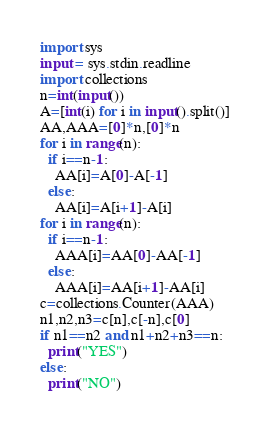<code> <loc_0><loc_0><loc_500><loc_500><_Python_>import sys
input = sys.stdin.readline
import collections
n=int(input())
A=[int(i) for i in input().split()]
AA,AAA=[0]*n,[0]*n
for i in range(n):
  if i==n-1:
    AA[i]=A[0]-A[-1]
  else:
    AA[i]=A[i+1]-A[i]
for i in range(n):
  if i==n-1:
    AAA[i]=AA[0]-AA[-1]
  else:
    AAA[i]=AA[i+1]-AA[i]
c=collections.Counter(AAA)
n1,n2,n3=c[n],c[-n],c[0]
if n1==n2 and n1+n2+n3==n:
  print("YES")
else:
  print("NO")</code> 